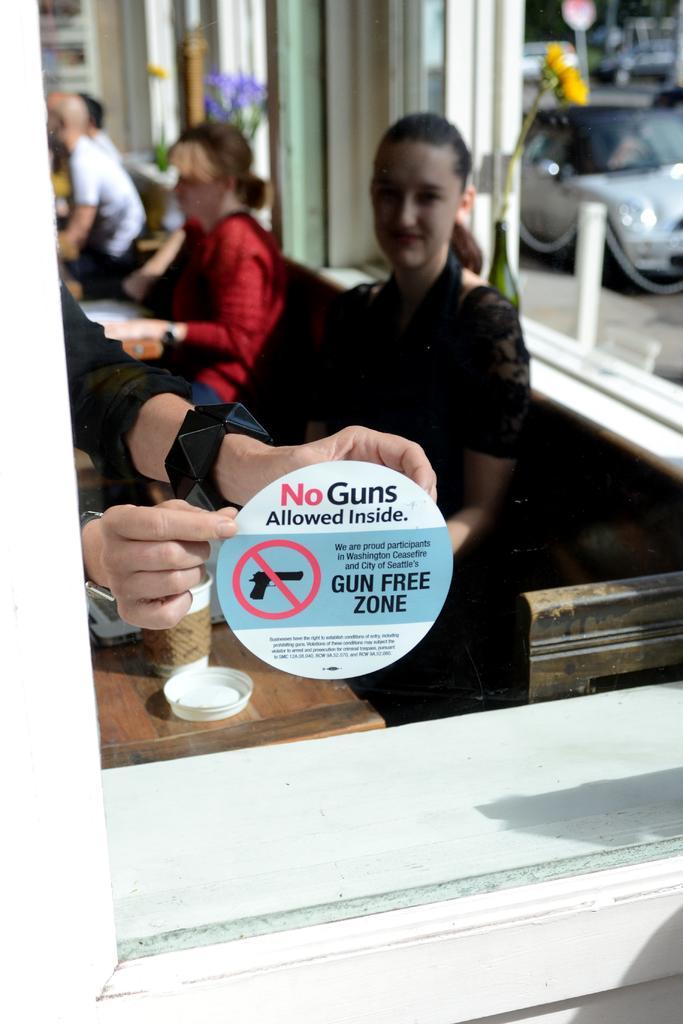How would you summarize this image in a sentence or two? In this image we can see a glass window on which we can see a sticker, through the glass window we can see a few people sitting near the table on which we can see cups are placed. The background of the image is slightly blurred, where we can see a car on the road and the board here. 